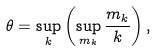Convert formula to latex. <formula><loc_0><loc_0><loc_500><loc_500>\theta = \sup _ { k } \left ( \sup _ { m _ { k } } \frac { m _ { k } } { k } \right ) ,</formula> 